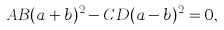<formula> <loc_0><loc_0><loc_500><loc_500>A B ( a + b ) ^ { 2 } - C D ( a - b ) ^ { 2 } = 0 ,</formula> 